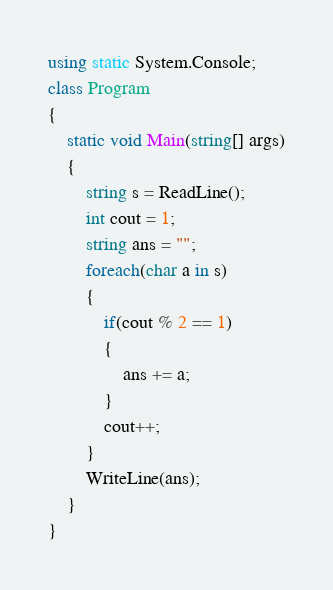Convert code to text. <code><loc_0><loc_0><loc_500><loc_500><_C#_>using static System.Console;
class Program
{
    static void Main(string[] args)
    {
        string s = ReadLine();
        int cout = 1;
        string ans = "";
        foreach(char a in s)
        {
            if(cout % 2 == 1)
            {
                ans += a;
            }
            cout++;
        }
        WriteLine(ans);
    }
}</code> 